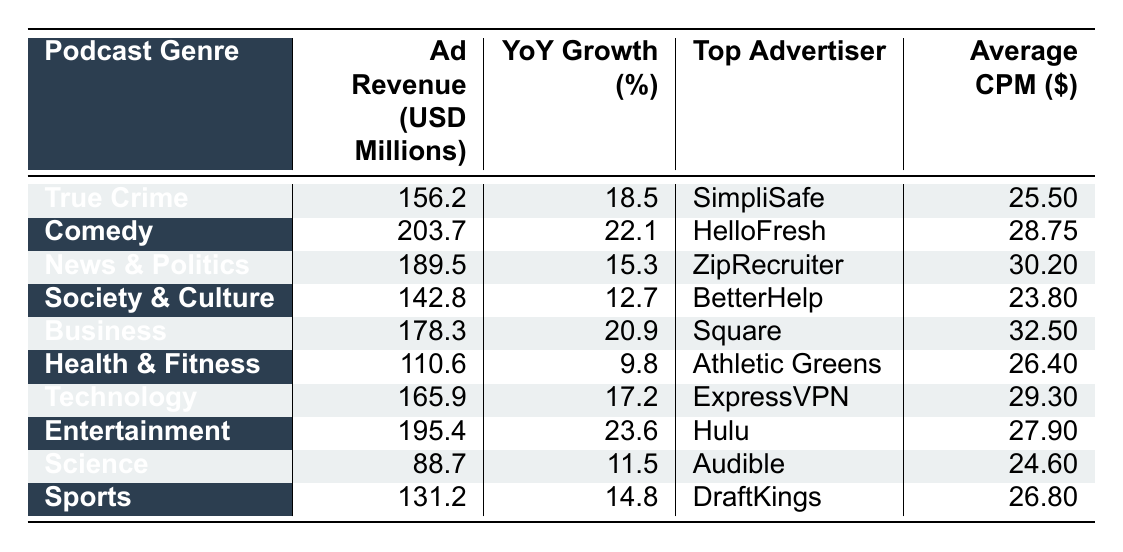What is the total ad revenue from the Comedy genre? The ad revenue for the Comedy genre is given as 203.7 million USD. Therefore, the total ad revenue from this genre is simply that figure.
Answer: 203.7 million USD Which podcast genre has the highest YoY growth percentage? The YoY growth percentages for each genre are listed. Comedy has 22.1%, which is the highest compared to all other genres.
Answer: Comedy What is the average CPM for the Technology genre? The table specifies the average CPM for Technology as 29.30 USD. Hence, that is the average CPM for the Technology genre.
Answer: 29.30 USD Which genre's top advertiser is BetterHelp? According to the table, BetterHelp is the top advertiser for the Society & Culture genre.
Answer: Society & Culture What is the difference in ad revenue between the Sports and Health & Fitness genres? The ad revenue for Sports is 131.2 million USD and for Health & Fitness is 110.6 million USD. The difference can be calculated as 131.2 - 110.6 = 20.6 million USD.
Answer: 20.6 million USD Is the ad revenue for the Science genre more than 100 million USD? The ad revenue for the Science genre is listed as 88.7 million USD, which is less than 100 million USD. Therefore, the statement is false.
Answer: No What is the average ad revenue for all genres listed? To find the average, first sum all the ad revenues: 156.2 + 203.7 + 189.5 + 142.8 + 178.3 + 110.6 + 165.9 + 195.4 + 88.7 + 131.2 = 1,505.3 million USD. Then, divide by the number of genres (10): 1,505.3 / 10 = 150.53 million USD.
Answer: 150.53 million USD Which genre has the lowest average CPM, and what is its value? Looking at the CPM values, Science has the lowest at 24.60 USD. Thus, Science is the genre with the lowest average CPM.
Answer: Science, 24.60 USD What percentage of the ad revenue does the True Crime genre represent compared to the total revenue of all genres? Total ad revenue is 1,505.3 million USD, and True Crime's revenue is 156.2 million USD. The percentage can be calculated as (156.2 / 1,505.3) * 100 ≈ 10.39%.
Answer: 10.39% Is the average CPM for Health & Fitness higher than that of Society & Culture? The average CPM for Health & Fitness is 26.40 USD, while for Society & Culture it is 23.80 USD. Since 26.40 is greater than 23.80, the statement is true.
Answer: Yes 